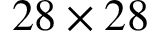Convert formula to latex. <formula><loc_0><loc_0><loc_500><loc_500>2 8 \times 2 8</formula> 